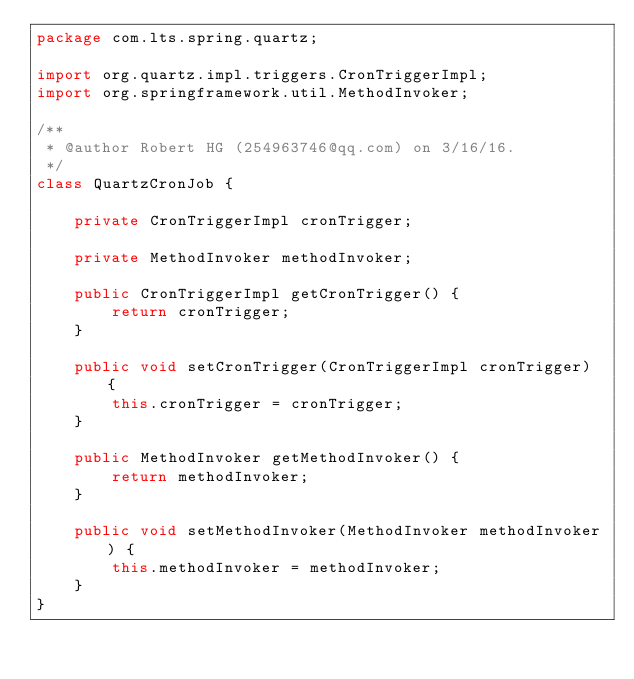<code> <loc_0><loc_0><loc_500><loc_500><_Java_>package com.lts.spring.quartz;

import org.quartz.impl.triggers.CronTriggerImpl;
import org.springframework.util.MethodInvoker;

/**
 * @author Robert HG (254963746@qq.com) on 3/16/16.
 */
class QuartzCronJob {

    private CronTriggerImpl cronTrigger;

    private MethodInvoker methodInvoker;

    public CronTriggerImpl getCronTrigger() {
        return cronTrigger;
    }

    public void setCronTrigger(CronTriggerImpl cronTrigger) {
        this.cronTrigger = cronTrigger;
    }

    public MethodInvoker getMethodInvoker() {
        return methodInvoker;
    }

    public void setMethodInvoker(MethodInvoker methodInvoker) {
        this.methodInvoker = methodInvoker;
    }
}
</code> 